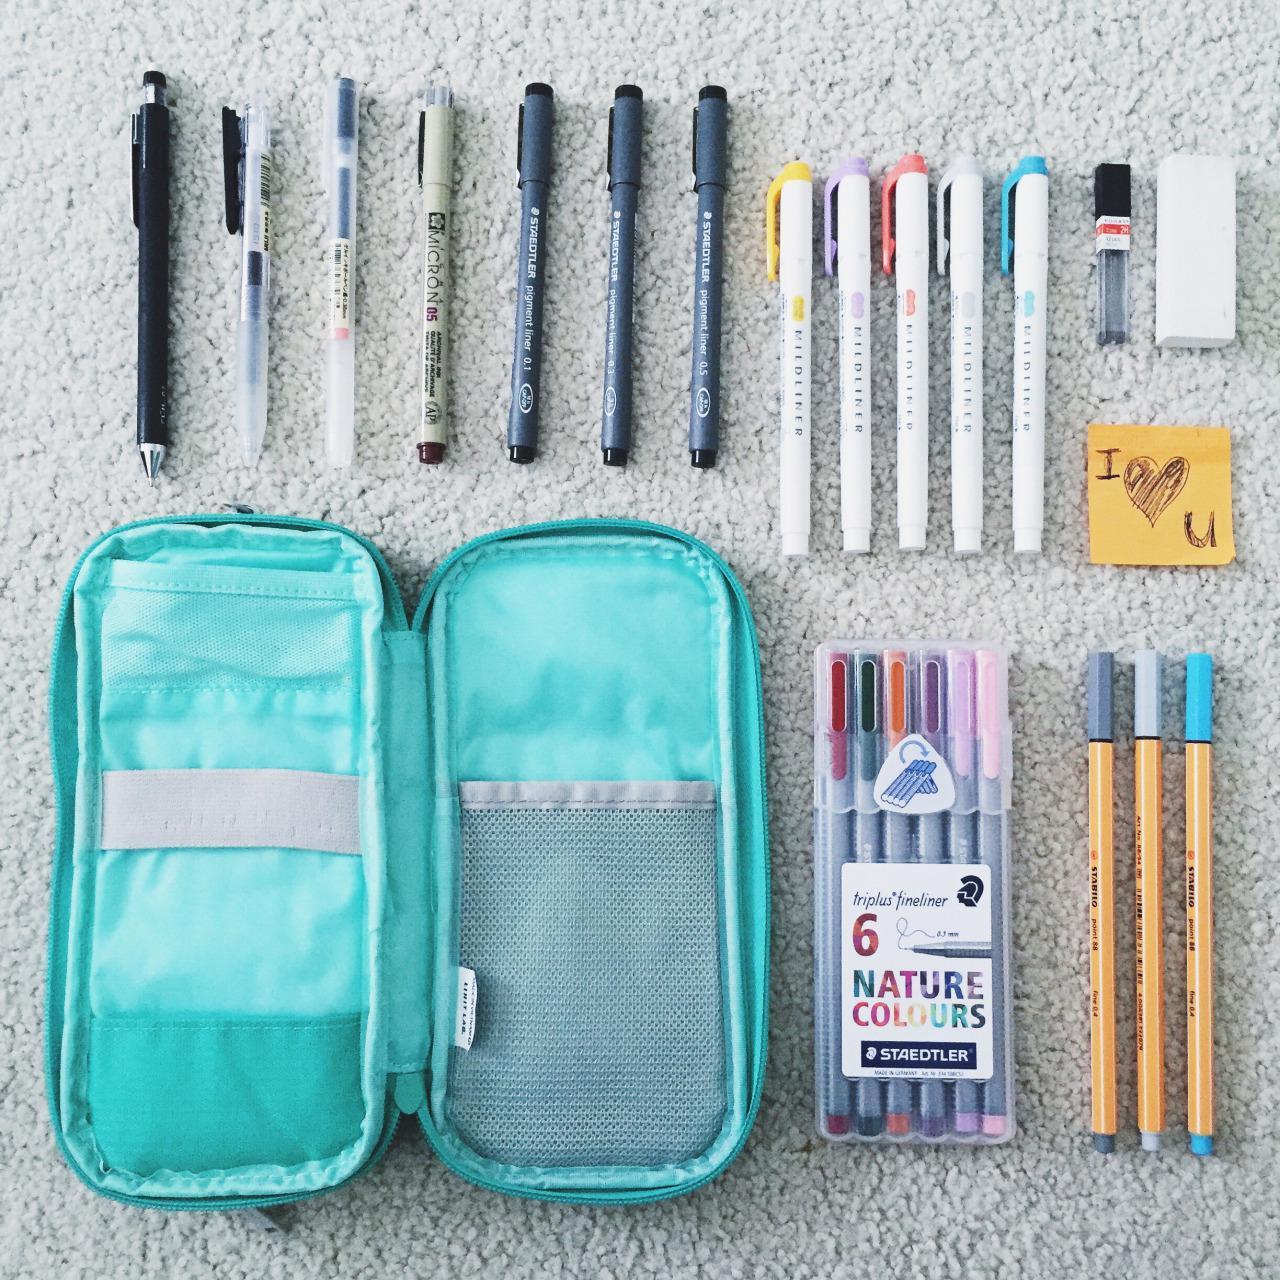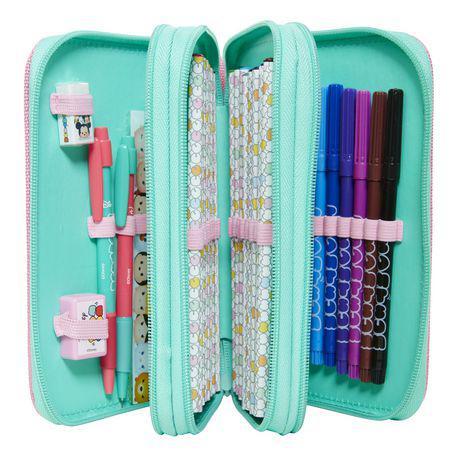The first image is the image on the left, the second image is the image on the right. Evaluate the accuracy of this statement regarding the images: "An image shows an opened case flanked by multiple different type implements.". Is it true? Answer yes or no. Yes. 